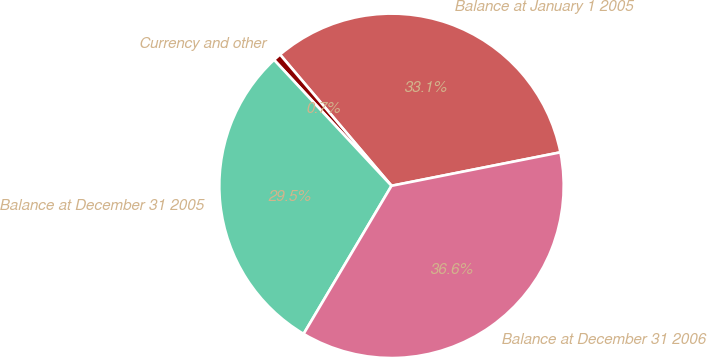Convert chart to OTSL. <chart><loc_0><loc_0><loc_500><loc_500><pie_chart><fcel>Balance at January 1 2005<fcel>Currency and other<fcel>Balance at December 31 2005<fcel>Balance at December 31 2006<nl><fcel>33.09%<fcel>0.74%<fcel>29.53%<fcel>36.64%<nl></chart> 